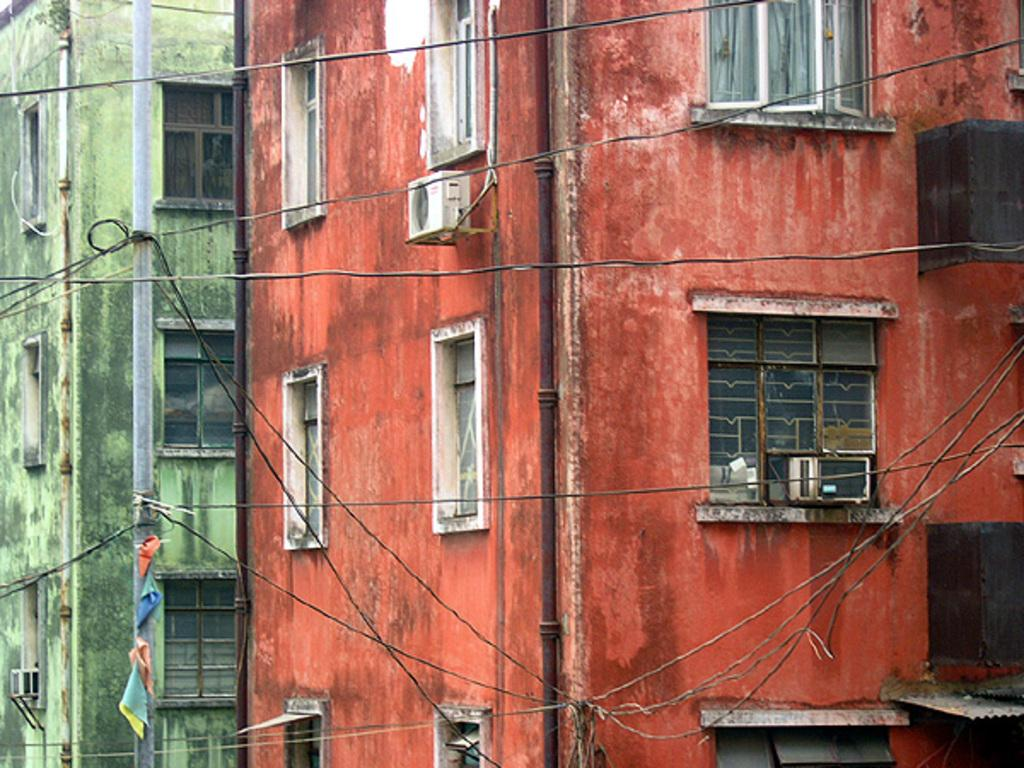What can be seen in the foreground of the image? There are cables in the foreground of the image. What is visible in the background of the image? Buildings, windows, pipes, air conditioners, and a pole are visible in the background of the image. Can you describe the buildings in the background? The buildings in the background have windows and air conditioners. What else is present in the background of the image? Pipes and a pole are also present in the background of the image. How many quarters are visible on the pole in the image? There are no quarters present in the image; the pole is not associated with any coins. What type of rifle is being used by the person in the image? There is no person or rifle present in the image. 